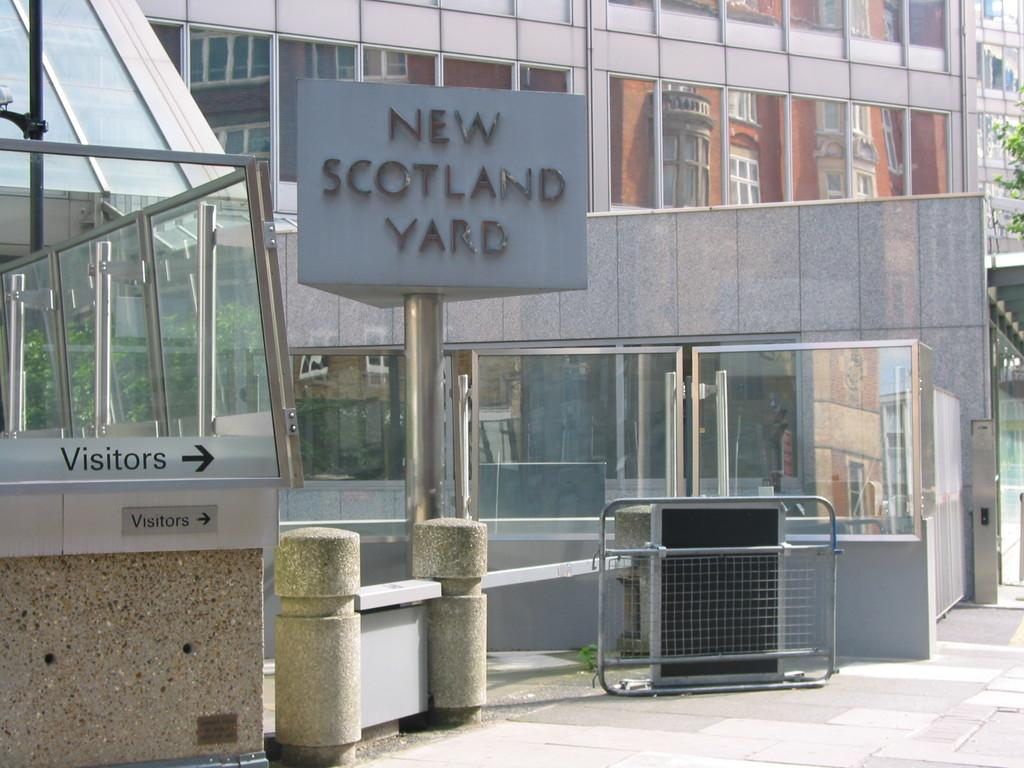What type of structures can be seen in the image? There are buildings in the image. What are the name boards and sign boards used for in the image? The name boards and sign boards provide information or directions in the image. What are the barrier poles used for in the image? The barrier poles are used to control or guide traffic or movement in the image. What type of vegetation is present in the image? There are trees in the image. What type of bed can be seen in the image? There is no bed present in the image. What nation is represented by the flag on the sign board in the image? There is no flag or nation mentioned in the image. 